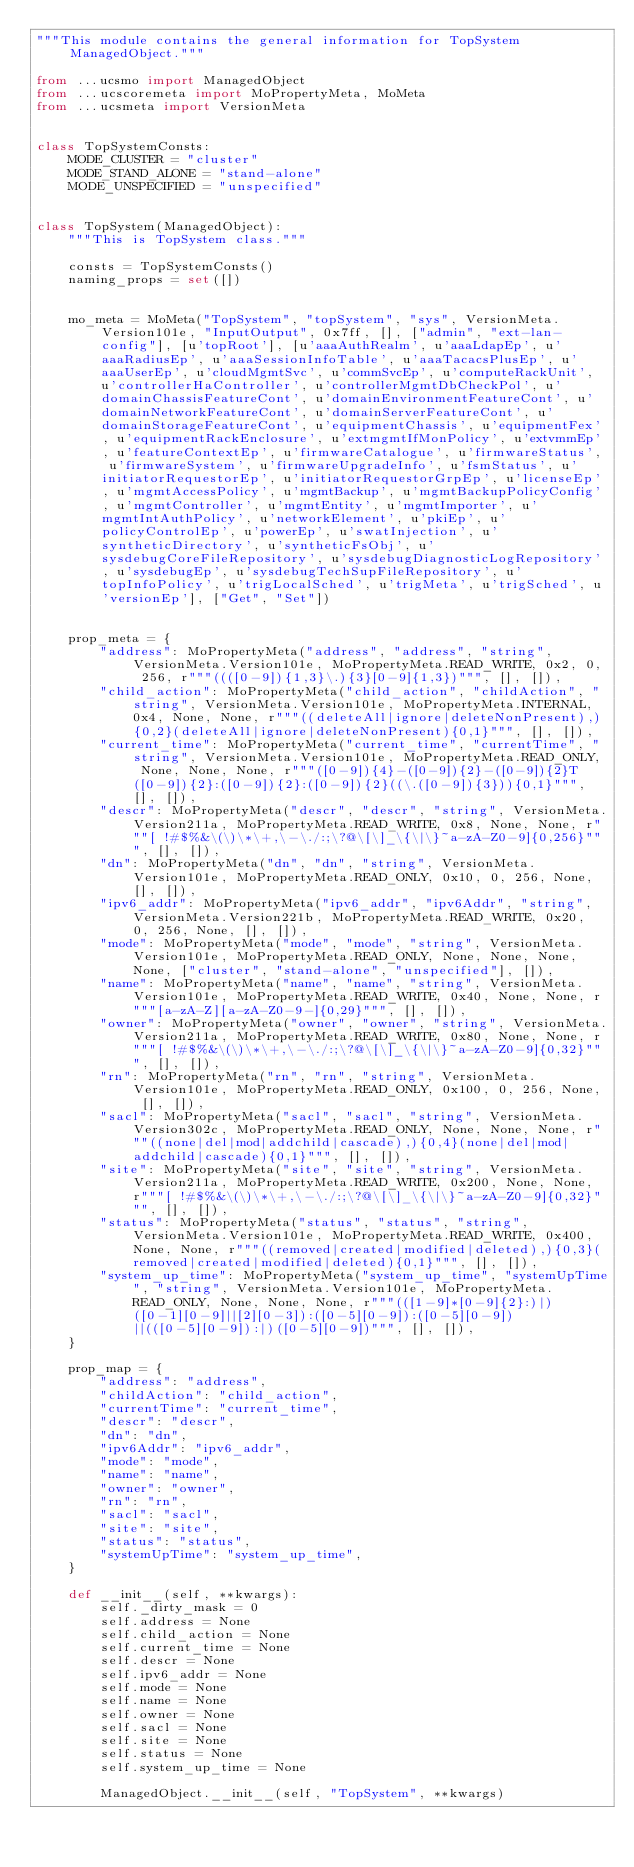Convert code to text. <code><loc_0><loc_0><loc_500><loc_500><_Python_>"""This module contains the general information for TopSystem ManagedObject."""

from ...ucsmo import ManagedObject
from ...ucscoremeta import MoPropertyMeta, MoMeta
from ...ucsmeta import VersionMeta


class TopSystemConsts:
    MODE_CLUSTER = "cluster"
    MODE_STAND_ALONE = "stand-alone"
    MODE_UNSPECIFIED = "unspecified"


class TopSystem(ManagedObject):
    """This is TopSystem class."""

    consts = TopSystemConsts()
    naming_props = set([])


    mo_meta = MoMeta("TopSystem", "topSystem", "sys", VersionMeta.Version101e, "InputOutput", 0x7ff, [], ["admin", "ext-lan-config"], [u'topRoot'], [u'aaaAuthRealm', u'aaaLdapEp', u'aaaRadiusEp', u'aaaSessionInfoTable', u'aaaTacacsPlusEp', u'aaaUserEp', u'cloudMgmtSvc', u'commSvcEp', u'computeRackUnit', u'controllerHaController', u'controllerMgmtDbCheckPol', u'domainChassisFeatureCont', u'domainEnvironmentFeatureCont', u'domainNetworkFeatureCont', u'domainServerFeatureCont', u'domainStorageFeatureCont', u'equipmentChassis', u'equipmentFex', u'equipmentRackEnclosure', u'extmgmtIfMonPolicy', u'extvmmEp', u'featureContextEp', u'firmwareCatalogue', u'firmwareStatus', u'firmwareSystem', u'firmwareUpgradeInfo', u'fsmStatus', u'initiatorRequestorEp', u'initiatorRequestorGrpEp', u'licenseEp', u'mgmtAccessPolicy', u'mgmtBackup', u'mgmtBackupPolicyConfig', u'mgmtController', u'mgmtEntity', u'mgmtImporter', u'mgmtIntAuthPolicy', u'networkElement', u'pkiEp', u'policyControlEp', u'powerEp', u'swatInjection', u'syntheticDirectory', u'syntheticFsObj', u'sysdebugCoreFileRepository', u'sysdebugDiagnosticLogRepository', u'sysdebugEp', u'sysdebugTechSupFileRepository', u'topInfoPolicy', u'trigLocalSched', u'trigMeta', u'trigSched', u'versionEp'], ["Get", "Set"])


    prop_meta = {
        "address": MoPropertyMeta("address", "address", "string", VersionMeta.Version101e, MoPropertyMeta.READ_WRITE, 0x2, 0, 256, r"""((([0-9]){1,3}\.){3}[0-9]{1,3})""", [], []), 
        "child_action": MoPropertyMeta("child_action", "childAction", "string", VersionMeta.Version101e, MoPropertyMeta.INTERNAL, 0x4, None, None, r"""((deleteAll|ignore|deleteNonPresent),){0,2}(deleteAll|ignore|deleteNonPresent){0,1}""", [], []), 
        "current_time": MoPropertyMeta("current_time", "currentTime", "string", VersionMeta.Version101e, MoPropertyMeta.READ_ONLY, None, None, None, r"""([0-9]){4}-([0-9]){2}-([0-9]){2}T([0-9]){2}:([0-9]){2}:([0-9]){2}((\.([0-9]){3})){0,1}""", [], []), 
        "descr": MoPropertyMeta("descr", "descr", "string", VersionMeta.Version211a, MoPropertyMeta.READ_WRITE, 0x8, None, None, r"""[ !#$%&\(\)\*\+,\-\./:;\?@\[\]_\{\|\}~a-zA-Z0-9]{0,256}""", [], []), 
        "dn": MoPropertyMeta("dn", "dn", "string", VersionMeta.Version101e, MoPropertyMeta.READ_ONLY, 0x10, 0, 256, None, [], []), 
        "ipv6_addr": MoPropertyMeta("ipv6_addr", "ipv6Addr", "string", VersionMeta.Version221b, MoPropertyMeta.READ_WRITE, 0x20, 0, 256, None, [], []), 
        "mode": MoPropertyMeta("mode", "mode", "string", VersionMeta.Version101e, MoPropertyMeta.READ_ONLY, None, None, None, None, ["cluster", "stand-alone", "unspecified"], []), 
        "name": MoPropertyMeta("name", "name", "string", VersionMeta.Version101e, MoPropertyMeta.READ_WRITE, 0x40, None, None, r"""[a-zA-Z][a-zA-Z0-9-]{0,29}""", [], []), 
        "owner": MoPropertyMeta("owner", "owner", "string", VersionMeta.Version211a, MoPropertyMeta.READ_WRITE, 0x80, None, None, r"""[ !#$%&\(\)\*\+,\-\./:;\?@\[\]_\{\|\}~a-zA-Z0-9]{0,32}""", [], []), 
        "rn": MoPropertyMeta("rn", "rn", "string", VersionMeta.Version101e, MoPropertyMeta.READ_ONLY, 0x100, 0, 256, None, [], []), 
        "sacl": MoPropertyMeta("sacl", "sacl", "string", VersionMeta.Version302c, MoPropertyMeta.READ_ONLY, None, None, None, r"""((none|del|mod|addchild|cascade),){0,4}(none|del|mod|addchild|cascade){0,1}""", [], []), 
        "site": MoPropertyMeta("site", "site", "string", VersionMeta.Version211a, MoPropertyMeta.READ_WRITE, 0x200, None, None, r"""[ !#$%&\(\)\*\+,\-\./:;\?@\[\]_\{\|\}~a-zA-Z0-9]{0,32}""", [], []), 
        "status": MoPropertyMeta("status", "status", "string", VersionMeta.Version101e, MoPropertyMeta.READ_WRITE, 0x400, None, None, r"""((removed|created|modified|deleted),){0,3}(removed|created|modified|deleted){0,1}""", [], []), 
        "system_up_time": MoPropertyMeta("system_up_time", "systemUpTime", "string", VersionMeta.Version101e, MoPropertyMeta.READ_ONLY, None, None, None, r"""(([1-9]*[0-9]{2}:)|)([0-1][0-9]||[2][0-3]):([0-5][0-9]):([0-5][0-9])||(([0-5][0-9]):|)([0-5][0-9])""", [], []), 
    }

    prop_map = {
        "address": "address", 
        "childAction": "child_action", 
        "currentTime": "current_time", 
        "descr": "descr", 
        "dn": "dn", 
        "ipv6Addr": "ipv6_addr", 
        "mode": "mode", 
        "name": "name", 
        "owner": "owner", 
        "rn": "rn", 
        "sacl": "sacl", 
        "site": "site", 
        "status": "status", 
        "systemUpTime": "system_up_time", 
    }

    def __init__(self, **kwargs):
        self._dirty_mask = 0
        self.address = None
        self.child_action = None
        self.current_time = None
        self.descr = None
        self.ipv6_addr = None
        self.mode = None
        self.name = None
        self.owner = None
        self.sacl = None
        self.site = None
        self.status = None
        self.system_up_time = None

        ManagedObject.__init__(self, "TopSystem", **kwargs)
</code> 